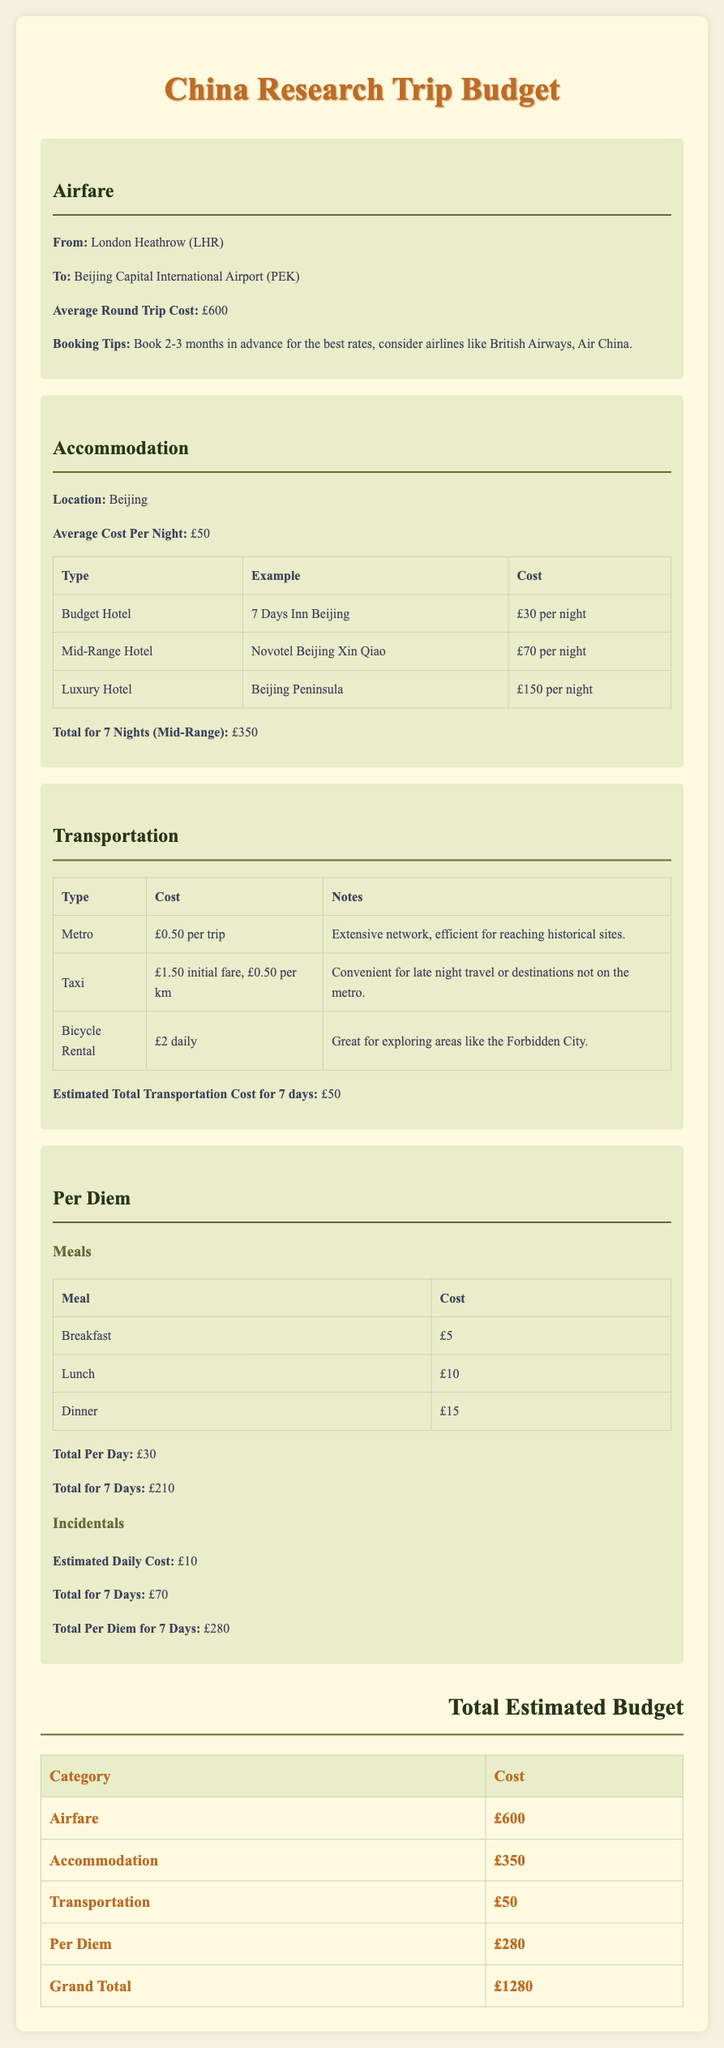what is the average round trip cost for airfare? The average round trip cost for airfare is stated in the budget section for airfare as £600.
Answer: £600 what is the average cost per night for accommodation? The document specifies that the average cost per night for accommodation in Beijing is £50.
Answer: £50 how much is the total for transportation estimated for 7 days? The estimated total transportation cost for 7 days is mentioned in the transportation section as £50.
Answer: £50 what is the total per diem for 7 days? The total per diem for meals and incidentals over 7 days is calculated and stated as £280 in the per diem section.
Answer: £280 what is the total estimated budget for the trip? The grand total for the trip is detailed in the total estimated budget section and is £1280.
Answer: £1280 which hotel is an example of a mid-range accommodation? The document provides an example of a mid-range hotel called Novotel Beijing Xin Qiao.
Answer: Novotel Beijing Xin Qiao how much does a bicycle rental cost per day? The daily cost for bicycle rental is indicated in the transportation section as £2.
Answer: £2 what is the total cost for meals per day? The total cost for meals per day during the trip is outlined in the per diem section as £30.
Answer: £30 what type of fare is charged for taxi transportation? The initial fare for taxi transportation is mentioned as £1.50, with £0.50 per km afterwards.
Answer: £1.50 initial fare, £0.50 per km 